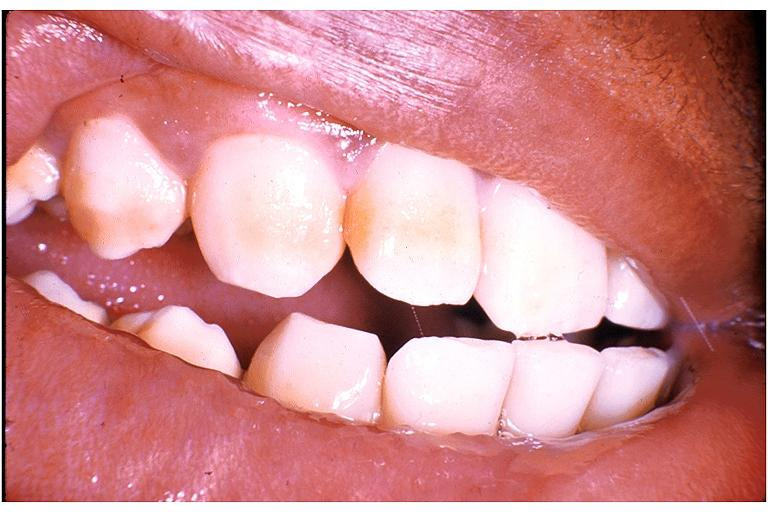where is this?
Answer the question using a single word or phrase. Oral 